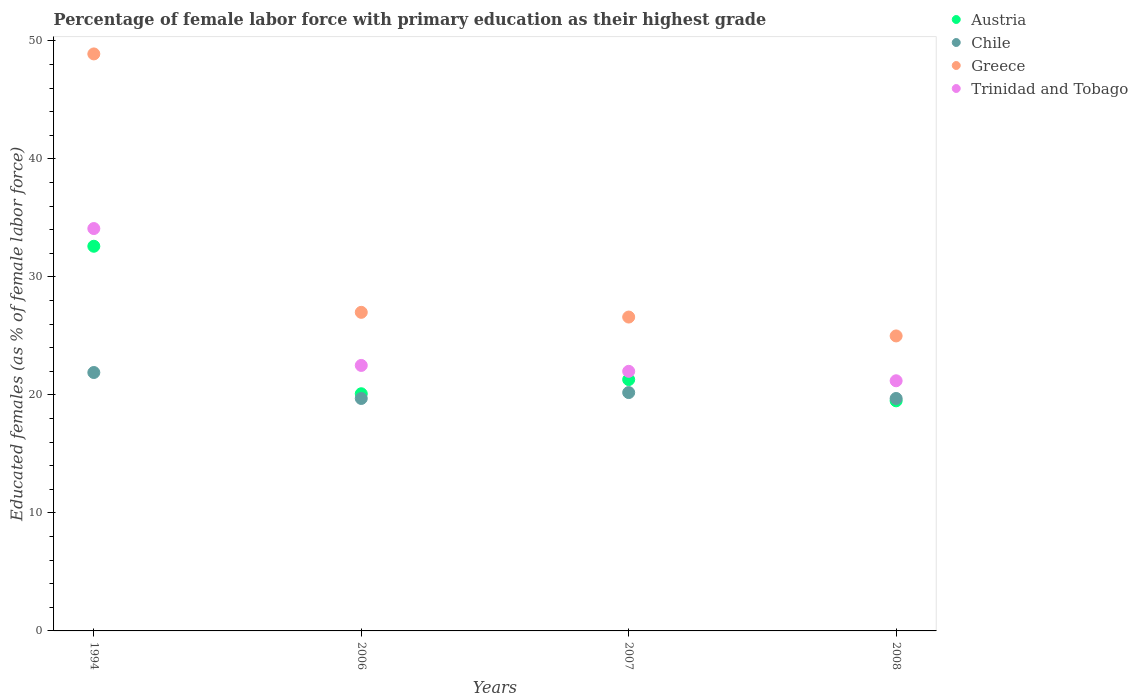Is the number of dotlines equal to the number of legend labels?
Offer a terse response. Yes. What is the percentage of female labor force with primary education in Chile in 2007?
Your answer should be compact. 20.2. Across all years, what is the maximum percentage of female labor force with primary education in Austria?
Keep it short and to the point. 32.6. Across all years, what is the minimum percentage of female labor force with primary education in Greece?
Make the answer very short. 25. In which year was the percentage of female labor force with primary education in Austria maximum?
Ensure brevity in your answer.  1994. What is the total percentage of female labor force with primary education in Chile in the graph?
Offer a very short reply. 81.5. What is the difference between the percentage of female labor force with primary education in Chile in 1994 and that in 2008?
Your answer should be compact. 2.2. What is the difference between the percentage of female labor force with primary education in Austria in 2006 and the percentage of female labor force with primary education in Greece in 2008?
Offer a very short reply. -4.9. What is the average percentage of female labor force with primary education in Trinidad and Tobago per year?
Your answer should be compact. 24.95. In how many years, is the percentage of female labor force with primary education in Chile greater than 6 %?
Your response must be concise. 4. What is the ratio of the percentage of female labor force with primary education in Greece in 1994 to that in 2006?
Provide a succinct answer. 1.81. Is the percentage of female labor force with primary education in Greece in 1994 less than that in 2007?
Ensure brevity in your answer.  No. Is the difference between the percentage of female labor force with primary education in Greece in 2006 and 2007 greater than the difference between the percentage of female labor force with primary education in Trinidad and Tobago in 2006 and 2007?
Your response must be concise. No. What is the difference between the highest and the second highest percentage of female labor force with primary education in Greece?
Provide a succinct answer. 21.9. What is the difference between the highest and the lowest percentage of female labor force with primary education in Greece?
Ensure brevity in your answer.  23.9. In how many years, is the percentage of female labor force with primary education in Austria greater than the average percentage of female labor force with primary education in Austria taken over all years?
Keep it short and to the point. 1. How many years are there in the graph?
Provide a succinct answer. 4. What is the difference between two consecutive major ticks on the Y-axis?
Provide a short and direct response. 10. Does the graph contain any zero values?
Ensure brevity in your answer.  No. Does the graph contain grids?
Offer a very short reply. No. Where does the legend appear in the graph?
Keep it short and to the point. Top right. How many legend labels are there?
Give a very brief answer. 4. How are the legend labels stacked?
Keep it short and to the point. Vertical. What is the title of the graph?
Ensure brevity in your answer.  Percentage of female labor force with primary education as their highest grade. Does "Micronesia" appear as one of the legend labels in the graph?
Offer a very short reply. No. What is the label or title of the Y-axis?
Provide a short and direct response. Educated females (as % of female labor force). What is the Educated females (as % of female labor force) of Austria in 1994?
Provide a succinct answer. 32.6. What is the Educated females (as % of female labor force) in Chile in 1994?
Provide a short and direct response. 21.9. What is the Educated females (as % of female labor force) of Greece in 1994?
Ensure brevity in your answer.  48.9. What is the Educated females (as % of female labor force) in Trinidad and Tobago in 1994?
Give a very brief answer. 34.1. What is the Educated females (as % of female labor force) in Austria in 2006?
Ensure brevity in your answer.  20.1. What is the Educated females (as % of female labor force) in Chile in 2006?
Offer a very short reply. 19.7. What is the Educated females (as % of female labor force) of Greece in 2006?
Offer a very short reply. 27. What is the Educated females (as % of female labor force) in Austria in 2007?
Provide a short and direct response. 21.3. What is the Educated females (as % of female labor force) in Chile in 2007?
Your answer should be compact. 20.2. What is the Educated females (as % of female labor force) in Greece in 2007?
Provide a short and direct response. 26.6. What is the Educated females (as % of female labor force) in Trinidad and Tobago in 2007?
Give a very brief answer. 22. What is the Educated females (as % of female labor force) in Austria in 2008?
Keep it short and to the point. 19.5. What is the Educated females (as % of female labor force) of Chile in 2008?
Provide a short and direct response. 19.7. What is the Educated females (as % of female labor force) in Greece in 2008?
Give a very brief answer. 25. What is the Educated females (as % of female labor force) of Trinidad and Tobago in 2008?
Your response must be concise. 21.2. Across all years, what is the maximum Educated females (as % of female labor force) in Austria?
Your response must be concise. 32.6. Across all years, what is the maximum Educated females (as % of female labor force) of Chile?
Your response must be concise. 21.9. Across all years, what is the maximum Educated females (as % of female labor force) in Greece?
Make the answer very short. 48.9. Across all years, what is the maximum Educated females (as % of female labor force) of Trinidad and Tobago?
Offer a very short reply. 34.1. Across all years, what is the minimum Educated females (as % of female labor force) of Chile?
Provide a short and direct response. 19.7. Across all years, what is the minimum Educated females (as % of female labor force) in Trinidad and Tobago?
Your answer should be very brief. 21.2. What is the total Educated females (as % of female labor force) in Austria in the graph?
Your response must be concise. 93.5. What is the total Educated females (as % of female labor force) in Chile in the graph?
Your answer should be very brief. 81.5. What is the total Educated females (as % of female labor force) of Greece in the graph?
Give a very brief answer. 127.5. What is the total Educated females (as % of female labor force) of Trinidad and Tobago in the graph?
Give a very brief answer. 99.8. What is the difference between the Educated females (as % of female labor force) in Chile in 1994 and that in 2006?
Provide a succinct answer. 2.2. What is the difference between the Educated females (as % of female labor force) in Greece in 1994 and that in 2006?
Your answer should be compact. 21.9. What is the difference between the Educated females (as % of female labor force) of Trinidad and Tobago in 1994 and that in 2006?
Your answer should be compact. 11.6. What is the difference between the Educated females (as % of female labor force) of Austria in 1994 and that in 2007?
Provide a short and direct response. 11.3. What is the difference between the Educated females (as % of female labor force) of Greece in 1994 and that in 2007?
Give a very brief answer. 22.3. What is the difference between the Educated females (as % of female labor force) in Austria in 1994 and that in 2008?
Your response must be concise. 13.1. What is the difference between the Educated females (as % of female labor force) of Chile in 1994 and that in 2008?
Make the answer very short. 2.2. What is the difference between the Educated females (as % of female labor force) of Greece in 1994 and that in 2008?
Offer a terse response. 23.9. What is the difference between the Educated females (as % of female labor force) in Trinidad and Tobago in 2006 and that in 2007?
Your answer should be compact. 0.5. What is the difference between the Educated females (as % of female labor force) in Chile in 2006 and that in 2008?
Your answer should be very brief. 0. What is the difference between the Educated females (as % of female labor force) in Greece in 2006 and that in 2008?
Make the answer very short. 2. What is the difference between the Educated females (as % of female labor force) of Austria in 2007 and that in 2008?
Make the answer very short. 1.8. What is the difference between the Educated females (as % of female labor force) of Chile in 2007 and that in 2008?
Ensure brevity in your answer.  0.5. What is the difference between the Educated females (as % of female labor force) of Trinidad and Tobago in 2007 and that in 2008?
Your answer should be compact. 0.8. What is the difference between the Educated females (as % of female labor force) in Austria in 1994 and the Educated females (as % of female labor force) in Greece in 2006?
Ensure brevity in your answer.  5.6. What is the difference between the Educated females (as % of female labor force) of Greece in 1994 and the Educated females (as % of female labor force) of Trinidad and Tobago in 2006?
Your response must be concise. 26.4. What is the difference between the Educated females (as % of female labor force) in Chile in 1994 and the Educated females (as % of female labor force) in Greece in 2007?
Your answer should be very brief. -4.7. What is the difference between the Educated females (as % of female labor force) in Chile in 1994 and the Educated females (as % of female labor force) in Trinidad and Tobago in 2007?
Provide a succinct answer. -0.1. What is the difference between the Educated females (as % of female labor force) of Greece in 1994 and the Educated females (as % of female labor force) of Trinidad and Tobago in 2007?
Your response must be concise. 26.9. What is the difference between the Educated females (as % of female labor force) in Austria in 1994 and the Educated females (as % of female labor force) in Greece in 2008?
Your answer should be compact. 7.6. What is the difference between the Educated females (as % of female labor force) of Greece in 1994 and the Educated females (as % of female labor force) of Trinidad and Tobago in 2008?
Your answer should be very brief. 27.7. What is the difference between the Educated females (as % of female labor force) in Austria in 2006 and the Educated females (as % of female labor force) in Chile in 2007?
Your response must be concise. -0.1. What is the difference between the Educated females (as % of female labor force) in Austria in 2006 and the Educated females (as % of female labor force) in Greece in 2007?
Make the answer very short. -6.5. What is the difference between the Educated females (as % of female labor force) of Chile in 2006 and the Educated females (as % of female labor force) of Greece in 2007?
Your answer should be compact. -6.9. What is the difference between the Educated females (as % of female labor force) in Chile in 2006 and the Educated females (as % of female labor force) in Trinidad and Tobago in 2007?
Offer a very short reply. -2.3. What is the difference between the Educated females (as % of female labor force) in Austria in 2006 and the Educated females (as % of female labor force) in Chile in 2008?
Provide a succinct answer. 0.4. What is the difference between the Educated females (as % of female labor force) in Austria in 2006 and the Educated females (as % of female labor force) in Greece in 2008?
Your answer should be very brief. -4.9. What is the difference between the Educated females (as % of female labor force) in Austria in 2006 and the Educated females (as % of female labor force) in Trinidad and Tobago in 2008?
Keep it short and to the point. -1.1. What is the difference between the Educated females (as % of female labor force) in Chile in 2006 and the Educated females (as % of female labor force) in Greece in 2008?
Make the answer very short. -5.3. What is the difference between the Educated females (as % of female labor force) of Chile in 2006 and the Educated females (as % of female labor force) of Trinidad and Tobago in 2008?
Your answer should be compact. -1.5. What is the difference between the Educated females (as % of female labor force) in Austria in 2007 and the Educated females (as % of female labor force) in Greece in 2008?
Keep it short and to the point. -3.7. What is the difference between the Educated females (as % of female labor force) of Chile in 2007 and the Educated females (as % of female labor force) of Greece in 2008?
Your answer should be compact. -4.8. What is the difference between the Educated females (as % of female labor force) in Greece in 2007 and the Educated females (as % of female labor force) in Trinidad and Tobago in 2008?
Keep it short and to the point. 5.4. What is the average Educated females (as % of female labor force) in Austria per year?
Your answer should be very brief. 23.38. What is the average Educated females (as % of female labor force) in Chile per year?
Keep it short and to the point. 20.38. What is the average Educated females (as % of female labor force) of Greece per year?
Offer a very short reply. 31.88. What is the average Educated females (as % of female labor force) in Trinidad and Tobago per year?
Provide a short and direct response. 24.95. In the year 1994, what is the difference between the Educated females (as % of female labor force) in Austria and Educated females (as % of female labor force) in Chile?
Offer a terse response. 10.7. In the year 1994, what is the difference between the Educated females (as % of female labor force) of Austria and Educated females (as % of female labor force) of Greece?
Provide a succinct answer. -16.3. In the year 1994, what is the difference between the Educated females (as % of female labor force) of Chile and Educated females (as % of female labor force) of Greece?
Offer a very short reply. -27. In the year 1994, what is the difference between the Educated females (as % of female labor force) in Chile and Educated females (as % of female labor force) in Trinidad and Tobago?
Ensure brevity in your answer.  -12.2. In the year 1994, what is the difference between the Educated females (as % of female labor force) of Greece and Educated females (as % of female labor force) of Trinidad and Tobago?
Ensure brevity in your answer.  14.8. In the year 2006, what is the difference between the Educated females (as % of female labor force) of Austria and Educated females (as % of female labor force) of Chile?
Give a very brief answer. 0.4. In the year 2006, what is the difference between the Educated females (as % of female labor force) of Austria and Educated females (as % of female labor force) of Trinidad and Tobago?
Keep it short and to the point. -2.4. In the year 2006, what is the difference between the Educated females (as % of female labor force) of Greece and Educated females (as % of female labor force) of Trinidad and Tobago?
Offer a very short reply. 4.5. In the year 2007, what is the difference between the Educated females (as % of female labor force) of Chile and Educated females (as % of female labor force) of Greece?
Your answer should be compact. -6.4. In the year 2007, what is the difference between the Educated females (as % of female labor force) in Chile and Educated females (as % of female labor force) in Trinidad and Tobago?
Provide a succinct answer. -1.8. In the year 2007, what is the difference between the Educated females (as % of female labor force) in Greece and Educated females (as % of female labor force) in Trinidad and Tobago?
Provide a short and direct response. 4.6. In the year 2008, what is the difference between the Educated females (as % of female labor force) in Austria and Educated females (as % of female labor force) in Chile?
Keep it short and to the point. -0.2. In the year 2008, what is the difference between the Educated females (as % of female labor force) in Chile and Educated females (as % of female labor force) in Greece?
Your response must be concise. -5.3. In the year 2008, what is the difference between the Educated females (as % of female labor force) in Chile and Educated females (as % of female labor force) in Trinidad and Tobago?
Offer a terse response. -1.5. What is the ratio of the Educated females (as % of female labor force) of Austria in 1994 to that in 2006?
Give a very brief answer. 1.62. What is the ratio of the Educated females (as % of female labor force) in Chile in 1994 to that in 2006?
Offer a terse response. 1.11. What is the ratio of the Educated females (as % of female labor force) in Greece in 1994 to that in 2006?
Offer a very short reply. 1.81. What is the ratio of the Educated females (as % of female labor force) of Trinidad and Tobago in 1994 to that in 2006?
Ensure brevity in your answer.  1.52. What is the ratio of the Educated females (as % of female labor force) in Austria in 1994 to that in 2007?
Provide a short and direct response. 1.53. What is the ratio of the Educated females (as % of female labor force) of Chile in 1994 to that in 2007?
Provide a succinct answer. 1.08. What is the ratio of the Educated females (as % of female labor force) in Greece in 1994 to that in 2007?
Keep it short and to the point. 1.84. What is the ratio of the Educated females (as % of female labor force) in Trinidad and Tobago in 1994 to that in 2007?
Ensure brevity in your answer.  1.55. What is the ratio of the Educated females (as % of female labor force) of Austria in 1994 to that in 2008?
Your response must be concise. 1.67. What is the ratio of the Educated females (as % of female labor force) of Chile in 1994 to that in 2008?
Provide a short and direct response. 1.11. What is the ratio of the Educated females (as % of female labor force) of Greece in 1994 to that in 2008?
Your response must be concise. 1.96. What is the ratio of the Educated females (as % of female labor force) of Trinidad and Tobago in 1994 to that in 2008?
Your answer should be very brief. 1.61. What is the ratio of the Educated females (as % of female labor force) of Austria in 2006 to that in 2007?
Keep it short and to the point. 0.94. What is the ratio of the Educated females (as % of female labor force) in Chile in 2006 to that in 2007?
Give a very brief answer. 0.98. What is the ratio of the Educated females (as % of female labor force) in Trinidad and Tobago in 2006 to that in 2007?
Give a very brief answer. 1.02. What is the ratio of the Educated females (as % of female labor force) of Austria in 2006 to that in 2008?
Ensure brevity in your answer.  1.03. What is the ratio of the Educated females (as % of female labor force) in Trinidad and Tobago in 2006 to that in 2008?
Keep it short and to the point. 1.06. What is the ratio of the Educated females (as % of female labor force) in Austria in 2007 to that in 2008?
Your response must be concise. 1.09. What is the ratio of the Educated females (as % of female labor force) of Chile in 2007 to that in 2008?
Make the answer very short. 1.03. What is the ratio of the Educated females (as % of female labor force) of Greece in 2007 to that in 2008?
Provide a succinct answer. 1.06. What is the ratio of the Educated females (as % of female labor force) in Trinidad and Tobago in 2007 to that in 2008?
Your answer should be compact. 1.04. What is the difference between the highest and the second highest Educated females (as % of female labor force) in Chile?
Provide a succinct answer. 1.7. What is the difference between the highest and the second highest Educated females (as % of female labor force) of Greece?
Offer a very short reply. 21.9. What is the difference between the highest and the second highest Educated females (as % of female labor force) of Trinidad and Tobago?
Provide a succinct answer. 11.6. What is the difference between the highest and the lowest Educated females (as % of female labor force) in Austria?
Your response must be concise. 13.1. What is the difference between the highest and the lowest Educated females (as % of female labor force) of Greece?
Your answer should be very brief. 23.9. What is the difference between the highest and the lowest Educated females (as % of female labor force) in Trinidad and Tobago?
Ensure brevity in your answer.  12.9. 